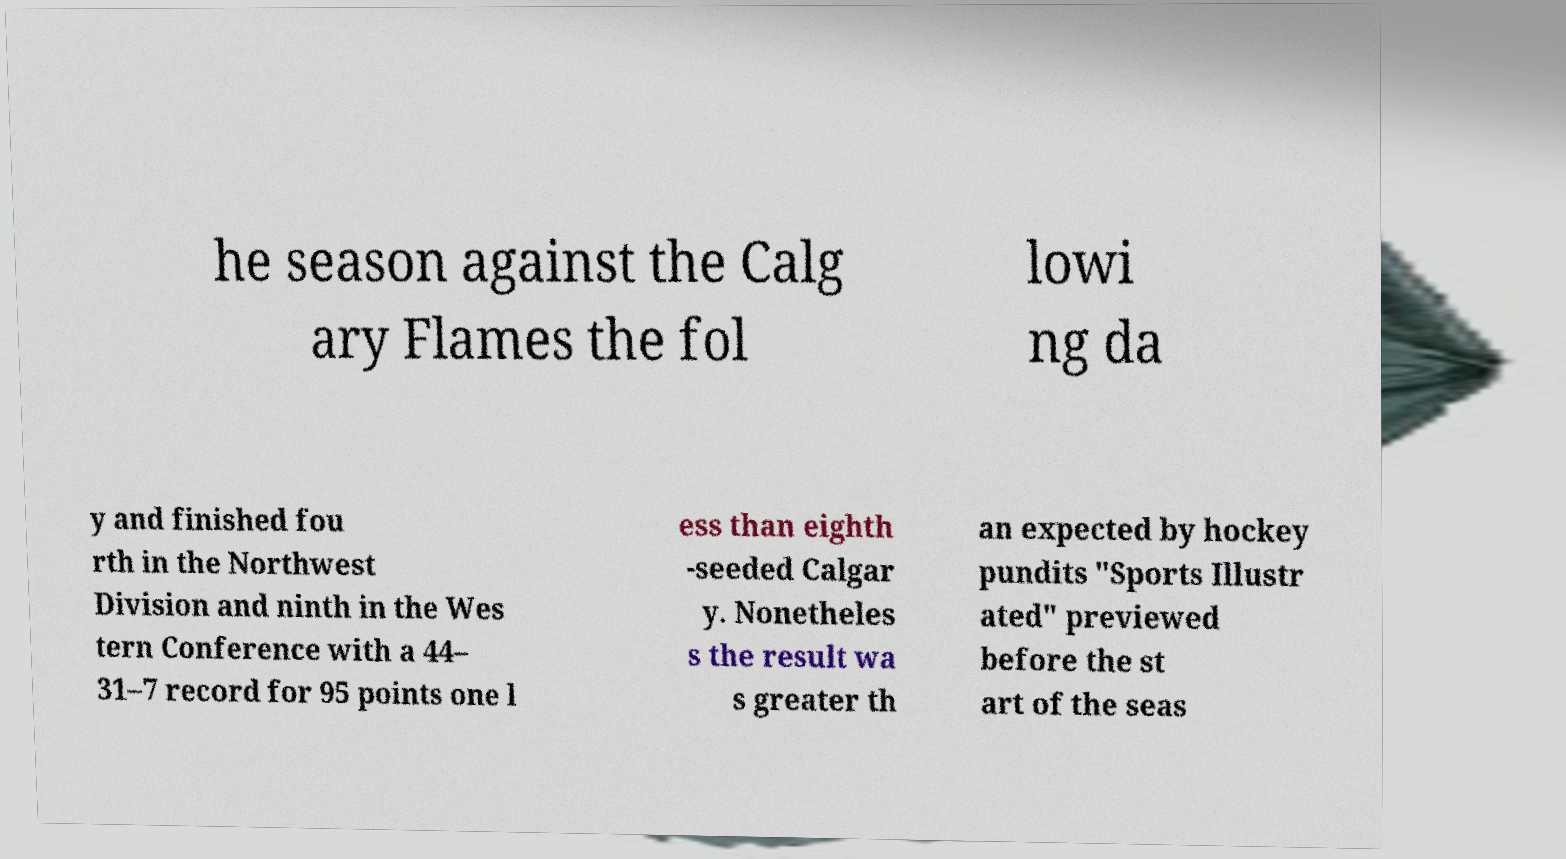What messages or text are displayed in this image? I need them in a readable, typed format. he season against the Calg ary Flames the fol lowi ng da y and finished fou rth in the Northwest Division and ninth in the Wes tern Conference with a 44– 31–7 record for 95 points one l ess than eighth -seeded Calgar y. Nonetheles s the result wa s greater th an expected by hockey pundits "Sports Illustr ated" previewed before the st art of the seas 